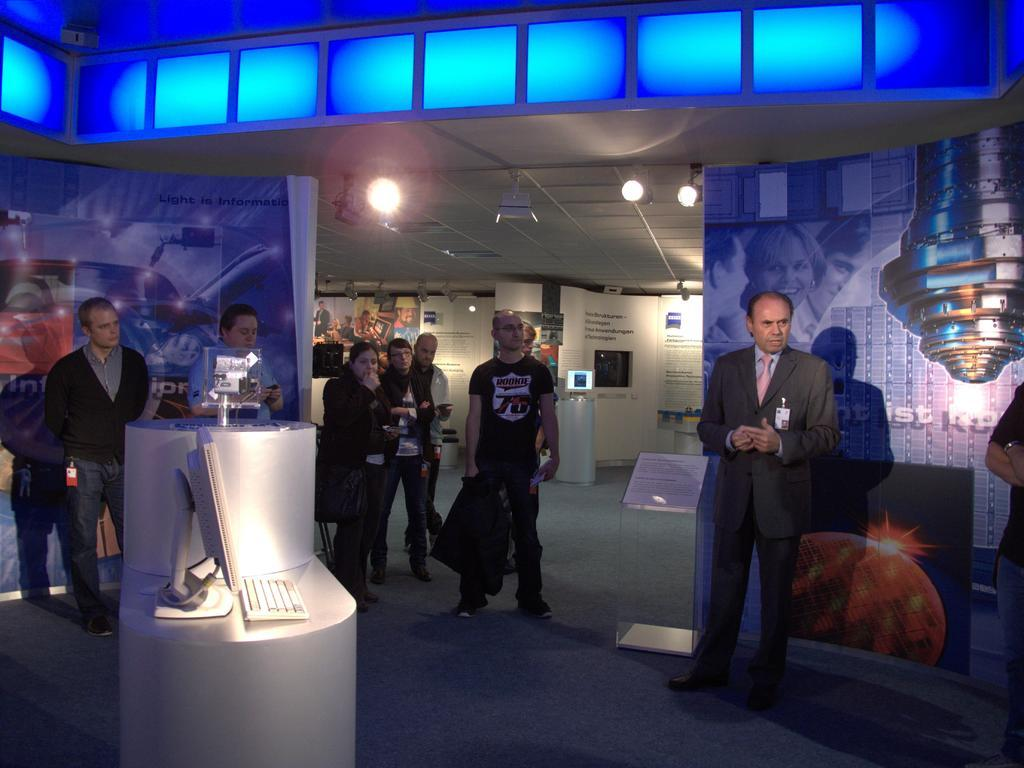How many people are in the image? There is a group of people in the image. What are the people doing in the image? The people are standing in the image. What objects are in front of the people? There is a monitor and a keyboard in front of the people. What can be seen in the background of the image? There are lights visible in the background of the image. What type of news is the queen announcing in the image? There is no queen or news present in the image. Can you see the airplane taking off in the image? There is no airplane present in the image. 